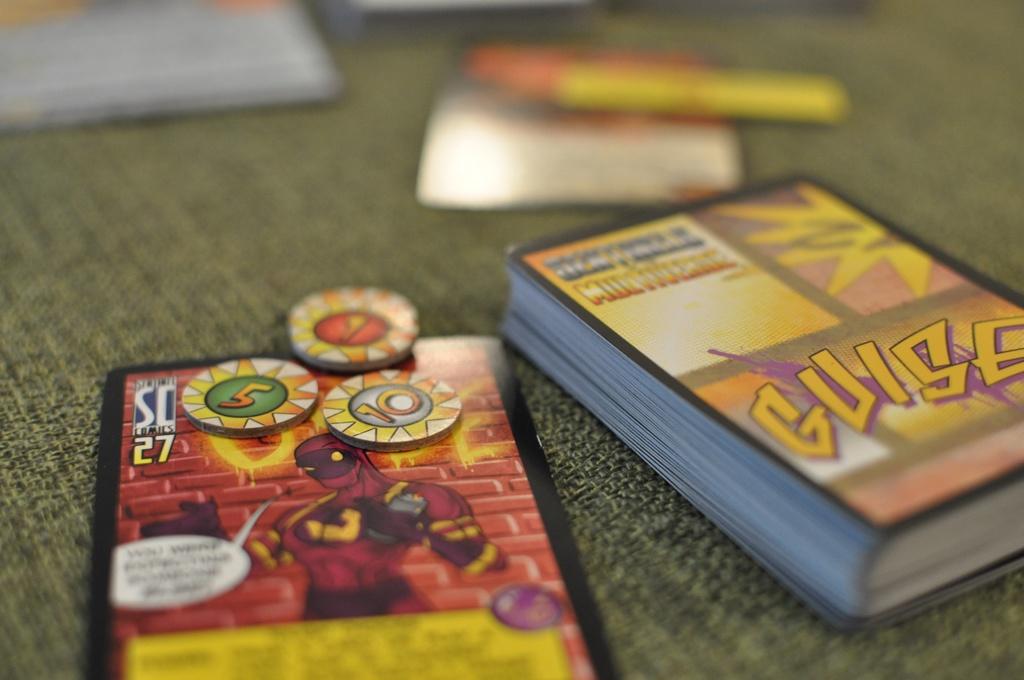Are these guise cards?
Keep it short and to the point. Yes. 